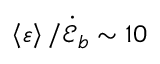Convert formula to latex. <formula><loc_0><loc_0><loc_500><loc_500>\left \langle \varepsilon \right \rangle / \dot { \mathcal { E } } _ { b } \sim 1 0 \</formula> 